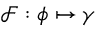Convert formula to latex. <formula><loc_0><loc_0><loc_500><loc_500>\mathcal { F } \colon \phi \mapsto \gamma</formula> 